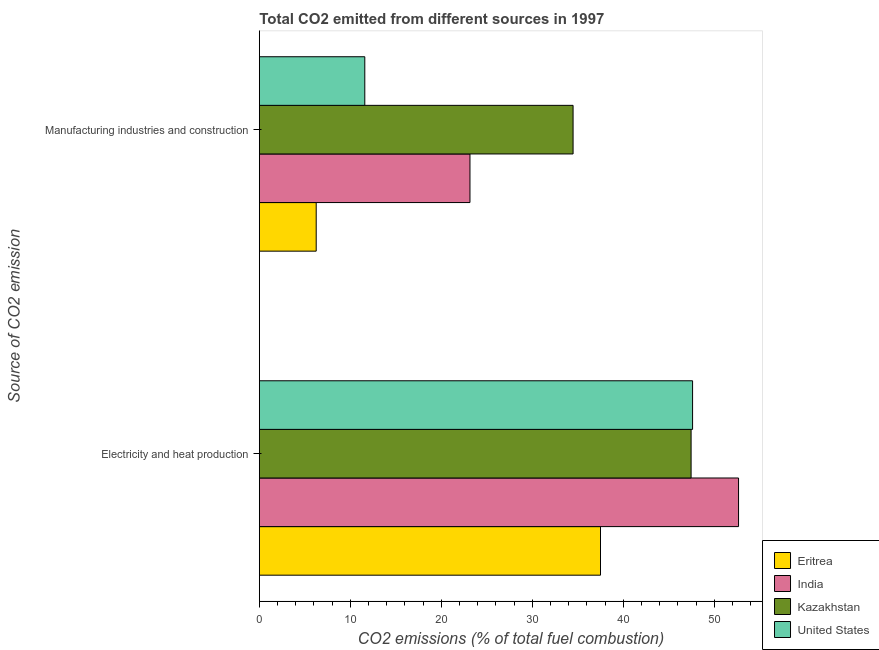How many different coloured bars are there?
Provide a succinct answer. 4. How many groups of bars are there?
Your answer should be compact. 2. How many bars are there on the 2nd tick from the top?
Make the answer very short. 4. What is the label of the 2nd group of bars from the top?
Your answer should be compact. Electricity and heat production. What is the co2 emissions due to manufacturing industries in India?
Make the answer very short. 23.15. Across all countries, what is the maximum co2 emissions due to manufacturing industries?
Your response must be concise. 34.49. Across all countries, what is the minimum co2 emissions due to manufacturing industries?
Provide a short and direct response. 6.25. In which country was the co2 emissions due to manufacturing industries maximum?
Provide a succinct answer. Kazakhstan. In which country was the co2 emissions due to manufacturing industries minimum?
Offer a terse response. Eritrea. What is the total co2 emissions due to manufacturing industries in the graph?
Provide a succinct answer. 75.48. What is the difference between the co2 emissions due to manufacturing industries in India and that in Kazakhstan?
Your answer should be very brief. -11.33. What is the difference between the co2 emissions due to electricity and heat production in India and the co2 emissions due to manufacturing industries in Kazakhstan?
Your response must be concise. 18.19. What is the average co2 emissions due to electricity and heat production per country?
Give a very brief answer. 46.31. What is the difference between the co2 emissions due to electricity and heat production and co2 emissions due to manufacturing industries in Eritrea?
Make the answer very short. 31.25. In how many countries, is the co2 emissions due to electricity and heat production greater than 6 %?
Provide a succinct answer. 4. What is the ratio of the co2 emissions due to manufacturing industries in Kazakhstan to that in India?
Offer a very short reply. 1.49. Is the co2 emissions due to manufacturing industries in Kazakhstan less than that in Eritrea?
Ensure brevity in your answer.  No. What does the 1st bar from the top in Electricity and heat production represents?
Your response must be concise. United States. What does the 2nd bar from the bottom in Electricity and heat production represents?
Your answer should be very brief. India. How many bars are there?
Offer a terse response. 8. Are all the bars in the graph horizontal?
Your answer should be compact. Yes. How many countries are there in the graph?
Give a very brief answer. 4. What is the difference between two consecutive major ticks on the X-axis?
Make the answer very short. 10. Does the graph contain any zero values?
Offer a terse response. No. Does the graph contain grids?
Provide a succinct answer. No. Where does the legend appear in the graph?
Give a very brief answer. Bottom right. How many legend labels are there?
Make the answer very short. 4. What is the title of the graph?
Your answer should be very brief. Total CO2 emitted from different sources in 1997. What is the label or title of the X-axis?
Make the answer very short. CO2 emissions (% of total fuel combustion). What is the label or title of the Y-axis?
Give a very brief answer. Source of CO2 emission. What is the CO2 emissions (% of total fuel combustion) in Eritrea in Electricity and heat production?
Make the answer very short. 37.5. What is the CO2 emissions (% of total fuel combustion) of India in Electricity and heat production?
Provide a succinct answer. 52.67. What is the CO2 emissions (% of total fuel combustion) of Kazakhstan in Electricity and heat production?
Your answer should be compact. 47.46. What is the CO2 emissions (% of total fuel combustion) in United States in Electricity and heat production?
Give a very brief answer. 47.62. What is the CO2 emissions (% of total fuel combustion) of Eritrea in Manufacturing industries and construction?
Offer a terse response. 6.25. What is the CO2 emissions (% of total fuel combustion) of India in Manufacturing industries and construction?
Make the answer very short. 23.15. What is the CO2 emissions (% of total fuel combustion) of Kazakhstan in Manufacturing industries and construction?
Your answer should be compact. 34.49. What is the CO2 emissions (% of total fuel combustion) in United States in Manufacturing industries and construction?
Keep it short and to the point. 11.59. Across all Source of CO2 emission, what is the maximum CO2 emissions (% of total fuel combustion) of Eritrea?
Keep it short and to the point. 37.5. Across all Source of CO2 emission, what is the maximum CO2 emissions (% of total fuel combustion) of India?
Your answer should be very brief. 52.67. Across all Source of CO2 emission, what is the maximum CO2 emissions (% of total fuel combustion) in Kazakhstan?
Provide a succinct answer. 47.46. Across all Source of CO2 emission, what is the maximum CO2 emissions (% of total fuel combustion) in United States?
Your answer should be compact. 47.62. Across all Source of CO2 emission, what is the minimum CO2 emissions (% of total fuel combustion) in Eritrea?
Provide a succinct answer. 6.25. Across all Source of CO2 emission, what is the minimum CO2 emissions (% of total fuel combustion) in India?
Your response must be concise. 23.15. Across all Source of CO2 emission, what is the minimum CO2 emissions (% of total fuel combustion) in Kazakhstan?
Your answer should be very brief. 34.49. Across all Source of CO2 emission, what is the minimum CO2 emissions (% of total fuel combustion) of United States?
Offer a terse response. 11.59. What is the total CO2 emissions (% of total fuel combustion) in Eritrea in the graph?
Provide a succinct answer. 43.75. What is the total CO2 emissions (% of total fuel combustion) of India in the graph?
Provide a succinct answer. 75.83. What is the total CO2 emissions (% of total fuel combustion) in Kazakhstan in the graph?
Provide a short and direct response. 81.94. What is the total CO2 emissions (% of total fuel combustion) of United States in the graph?
Your answer should be compact. 59.21. What is the difference between the CO2 emissions (% of total fuel combustion) of Eritrea in Electricity and heat production and that in Manufacturing industries and construction?
Offer a very short reply. 31.25. What is the difference between the CO2 emissions (% of total fuel combustion) in India in Electricity and heat production and that in Manufacturing industries and construction?
Ensure brevity in your answer.  29.52. What is the difference between the CO2 emissions (% of total fuel combustion) of Kazakhstan in Electricity and heat production and that in Manufacturing industries and construction?
Make the answer very short. 12.97. What is the difference between the CO2 emissions (% of total fuel combustion) of United States in Electricity and heat production and that in Manufacturing industries and construction?
Offer a terse response. 36.03. What is the difference between the CO2 emissions (% of total fuel combustion) of Eritrea in Electricity and heat production and the CO2 emissions (% of total fuel combustion) of India in Manufacturing industries and construction?
Ensure brevity in your answer.  14.35. What is the difference between the CO2 emissions (% of total fuel combustion) of Eritrea in Electricity and heat production and the CO2 emissions (% of total fuel combustion) of Kazakhstan in Manufacturing industries and construction?
Your answer should be compact. 3.01. What is the difference between the CO2 emissions (% of total fuel combustion) of Eritrea in Electricity and heat production and the CO2 emissions (% of total fuel combustion) of United States in Manufacturing industries and construction?
Give a very brief answer. 25.91. What is the difference between the CO2 emissions (% of total fuel combustion) of India in Electricity and heat production and the CO2 emissions (% of total fuel combustion) of Kazakhstan in Manufacturing industries and construction?
Ensure brevity in your answer.  18.19. What is the difference between the CO2 emissions (% of total fuel combustion) in India in Electricity and heat production and the CO2 emissions (% of total fuel combustion) in United States in Manufacturing industries and construction?
Ensure brevity in your answer.  41.08. What is the difference between the CO2 emissions (% of total fuel combustion) in Kazakhstan in Electricity and heat production and the CO2 emissions (% of total fuel combustion) in United States in Manufacturing industries and construction?
Ensure brevity in your answer.  35.87. What is the average CO2 emissions (% of total fuel combustion) in Eritrea per Source of CO2 emission?
Ensure brevity in your answer.  21.88. What is the average CO2 emissions (% of total fuel combustion) in India per Source of CO2 emission?
Offer a very short reply. 37.91. What is the average CO2 emissions (% of total fuel combustion) of Kazakhstan per Source of CO2 emission?
Provide a short and direct response. 40.97. What is the average CO2 emissions (% of total fuel combustion) of United States per Source of CO2 emission?
Your answer should be very brief. 29.61. What is the difference between the CO2 emissions (% of total fuel combustion) of Eritrea and CO2 emissions (% of total fuel combustion) of India in Electricity and heat production?
Your answer should be compact. -15.17. What is the difference between the CO2 emissions (% of total fuel combustion) of Eritrea and CO2 emissions (% of total fuel combustion) of Kazakhstan in Electricity and heat production?
Provide a short and direct response. -9.96. What is the difference between the CO2 emissions (% of total fuel combustion) in Eritrea and CO2 emissions (% of total fuel combustion) in United States in Electricity and heat production?
Give a very brief answer. -10.12. What is the difference between the CO2 emissions (% of total fuel combustion) of India and CO2 emissions (% of total fuel combustion) of Kazakhstan in Electricity and heat production?
Make the answer very short. 5.22. What is the difference between the CO2 emissions (% of total fuel combustion) of India and CO2 emissions (% of total fuel combustion) of United States in Electricity and heat production?
Make the answer very short. 5.05. What is the difference between the CO2 emissions (% of total fuel combustion) of Kazakhstan and CO2 emissions (% of total fuel combustion) of United States in Electricity and heat production?
Offer a terse response. -0.16. What is the difference between the CO2 emissions (% of total fuel combustion) of Eritrea and CO2 emissions (% of total fuel combustion) of India in Manufacturing industries and construction?
Provide a succinct answer. -16.9. What is the difference between the CO2 emissions (% of total fuel combustion) in Eritrea and CO2 emissions (% of total fuel combustion) in Kazakhstan in Manufacturing industries and construction?
Provide a succinct answer. -28.24. What is the difference between the CO2 emissions (% of total fuel combustion) of Eritrea and CO2 emissions (% of total fuel combustion) of United States in Manufacturing industries and construction?
Offer a terse response. -5.34. What is the difference between the CO2 emissions (% of total fuel combustion) in India and CO2 emissions (% of total fuel combustion) in Kazakhstan in Manufacturing industries and construction?
Your response must be concise. -11.33. What is the difference between the CO2 emissions (% of total fuel combustion) of India and CO2 emissions (% of total fuel combustion) of United States in Manufacturing industries and construction?
Make the answer very short. 11.56. What is the difference between the CO2 emissions (% of total fuel combustion) in Kazakhstan and CO2 emissions (% of total fuel combustion) in United States in Manufacturing industries and construction?
Make the answer very short. 22.89. What is the ratio of the CO2 emissions (% of total fuel combustion) in Eritrea in Electricity and heat production to that in Manufacturing industries and construction?
Your answer should be very brief. 6. What is the ratio of the CO2 emissions (% of total fuel combustion) in India in Electricity and heat production to that in Manufacturing industries and construction?
Keep it short and to the point. 2.28. What is the ratio of the CO2 emissions (% of total fuel combustion) of Kazakhstan in Electricity and heat production to that in Manufacturing industries and construction?
Make the answer very short. 1.38. What is the ratio of the CO2 emissions (% of total fuel combustion) in United States in Electricity and heat production to that in Manufacturing industries and construction?
Your answer should be compact. 4.11. What is the difference between the highest and the second highest CO2 emissions (% of total fuel combustion) in Eritrea?
Keep it short and to the point. 31.25. What is the difference between the highest and the second highest CO2 emissions (% of total fuel combustion) in India?
Your response must be concise. 29.52. What is the difference between the highest and the second highest CO2 emissions (% of total fuel combustion) in Kazakhstan?
Make the answer very short. 12.97. What is the difference between the highest and the second highest CO2 emissions (% of total fuel combustion) of United States?
Offer a terse response. 36.03. What is the difference between the highest and the lowest CO2 emissions (% of total fuel combustion) in Eritrea?
Ensure brevity in your answer.  31.25. What is the difference between the highest and the lowest CO2 emissions (% of total fuel combustion) of India?
Keep it short and to the point. 29.52. What is the difference between the highest and the lowest CO2 emissions (% of total fuel combustion) of Kazakhstan?
Give a very brief answer. 12.97. What is the difference between the highest and the lowest CO2 emissions (% of total fuel combustion) in United States?
Give a very brief answer. 36.03. 